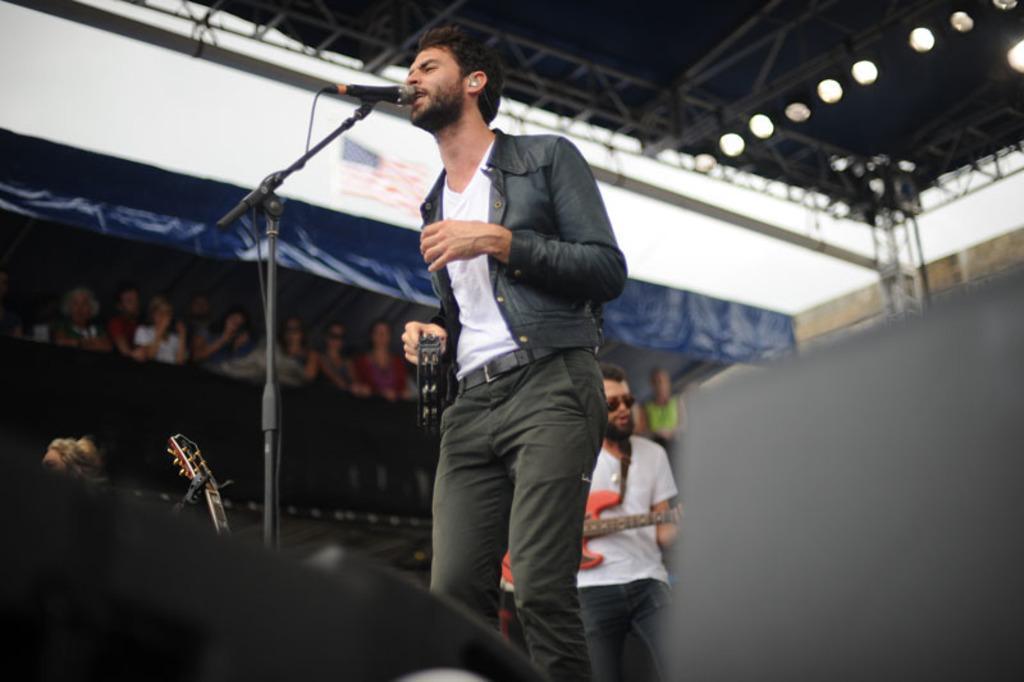Could you give a brief overview of what you see in this image? In the image there is a man in jacket singing on mic on the stage, behind him there is a man playing guitar, there are lights over the ceiling, on the left side it seems to be a tent with a flag above it and over the top it's sky. 